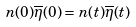Convert formula to latex. <formula><loc_0><loc_0><loc_500><loc_500>n ( 0 ) \overline { \eta } ( 0 ) = n ( t ) \overline { \eta } ( t )</formula> 